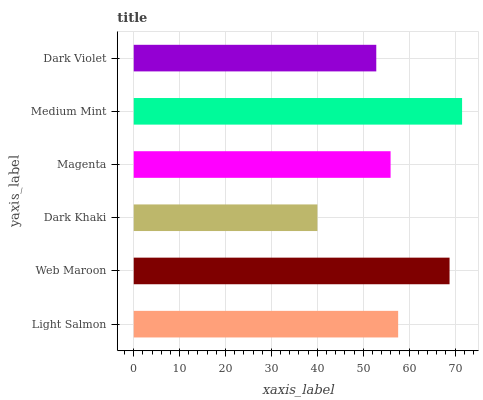Is Dark Khaki the minimum?
Answer yes or no. Yes. Is Medium Mint the maximum?
Answer yes or no. Yes. Is Web Maroon the minimum?
Answer yes or no. No. Is Web Maroon the maximum?
Answer yes or no. No. Is Web Maroon greater than Light Salmon?
Answer yes or no. Yes. Is Light Salmon less than Web Maroon?
Answer yes or no. Yes. Is Light Salmon greater than Web Maroon?
Answer yes or no. No. Is Web Maroon less than Light Salmon?
Answer yes or no. No. Is Light Salmon the high median?
Answer yes or no. Yes. Is Magenta the low median?
Answer yes or no. Yes. Is Dark Violet the high median?
Answer yes or no. No. Is Light Salmon the low median?
Answer yes or no. No. 